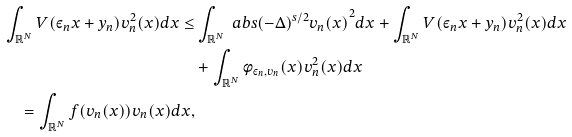Convert formula to latex. <formula><loc_0><loc_0><loc_500><loc_500>\int _ { \mathbb { R } ^ { N } } V ( \varepsilon _ { n } x + y _ { n } ) v _ { n } ^ { 2 } ( x ) d x \leq & \int _ { \mathbb { R } ^ { N } } \ a b s { ( - \Delta ) ^ { s / 2 } v _ { n } ( x ) } ^ { 2 } d x + \int _ { \mathbb { R } ^ { N } } V ( \varepsilon _ { n } x + y _ { n } ) v _ { n } ^ { 2 } ( x ) d x \\ & + \int _ { \mathbb { R } ^ { N } } \phi _ { \varepsilon _ { n } , v _ { n } } ( x ) v _ { n } ^ { 2 } ( x ) d x \\ = \int _ { \mathbb { R } ^ { N } } f ( v _ { n } ( x ) ) v _ { n } ( x ) d x ,</formula> 